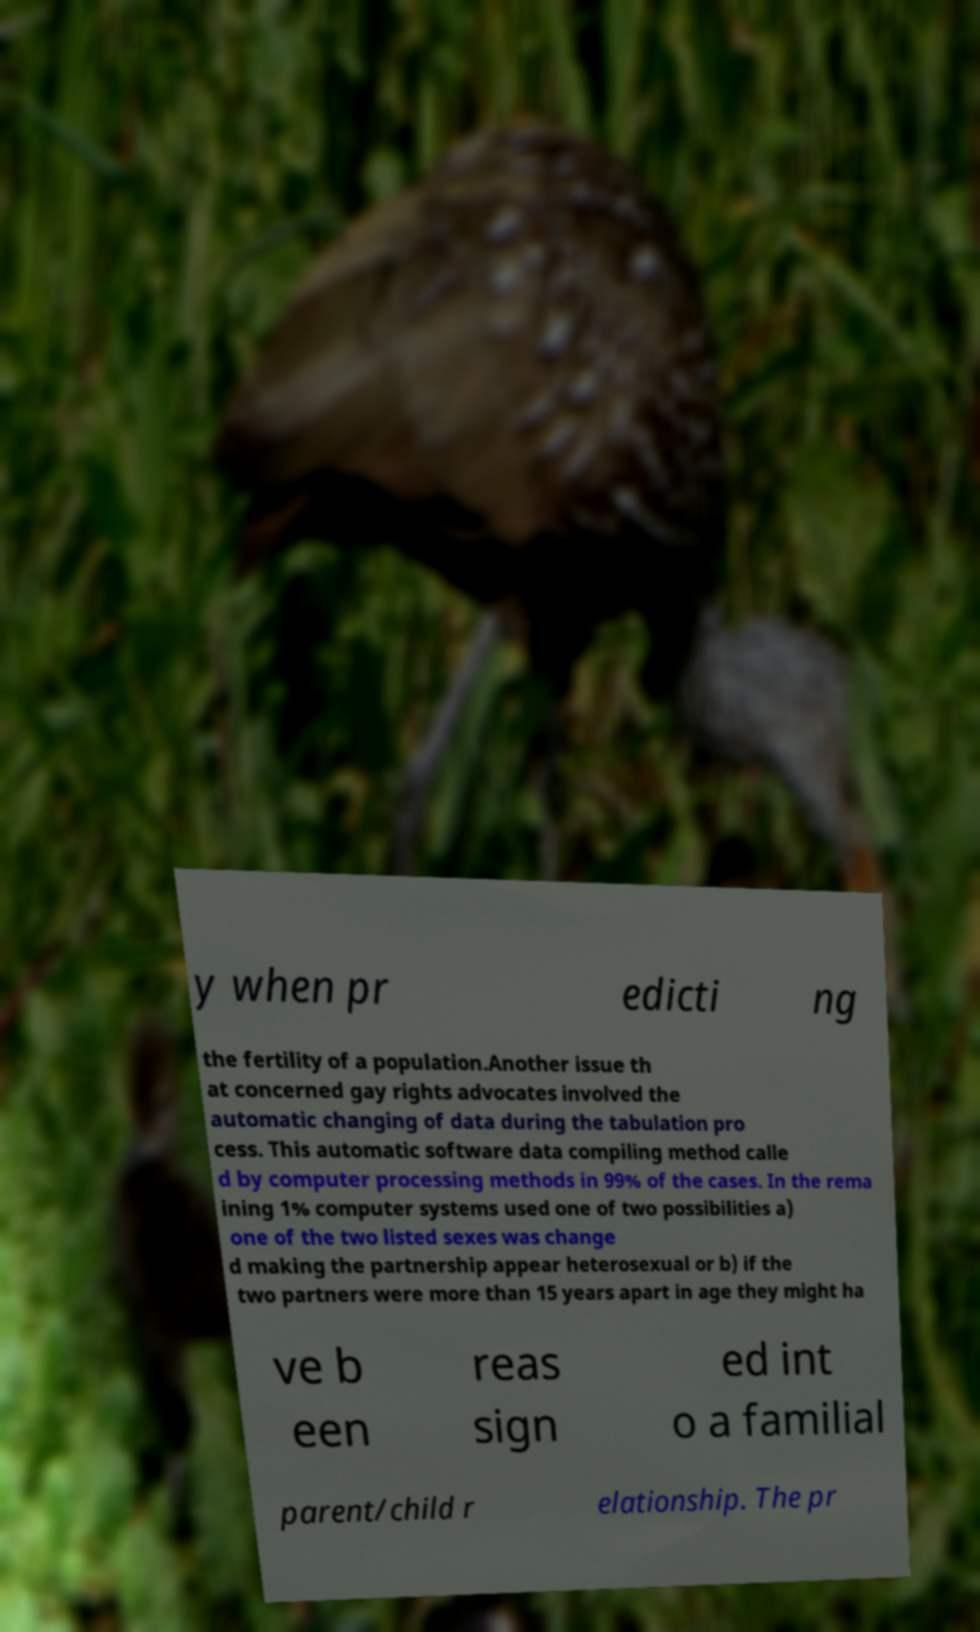Please identify and transcribe the text found in this image. y when pr edicti ng the fertility of a population.Another issue th at concerned gay rights advocates involved the automatic changing of data during the tabulation pro cess. This automatic software data compiling method calle d by computer processing methods in 99% of the cases. In the rema ining 1% computer systems used one of two possibilities a) one of the two listed sexes was change d making the partnership appear heterosexual or b) if the two partners were more than 15 years apart in age they might ha ve b een reas sign ed int o a familial parent/child r elationship. The pr 